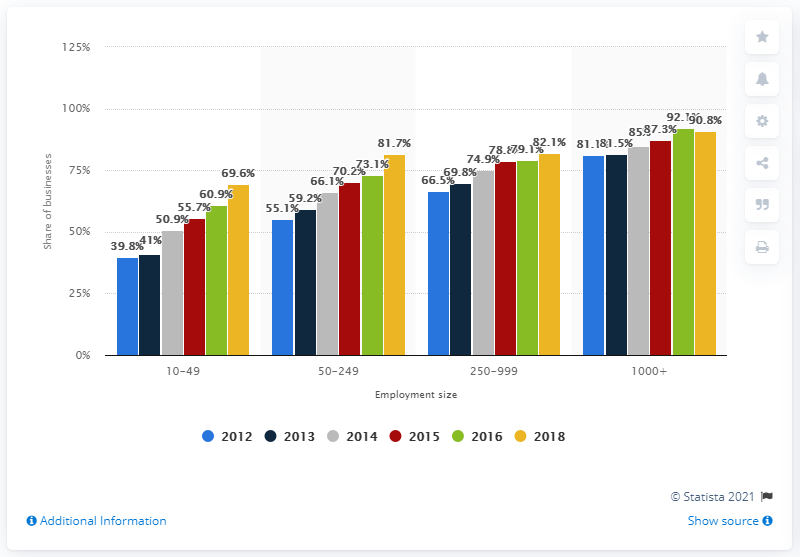Indicate a few pertinent items in this graphic. According to data from the United Kingdom (UK) from 2012 to 2013, the average percentage of businesses using social media was 40.4% for employment sizes ranging from 10 to 49 employees. In 2012, approximately 60.6% of businesses in the United Kingdom used social media on average. 